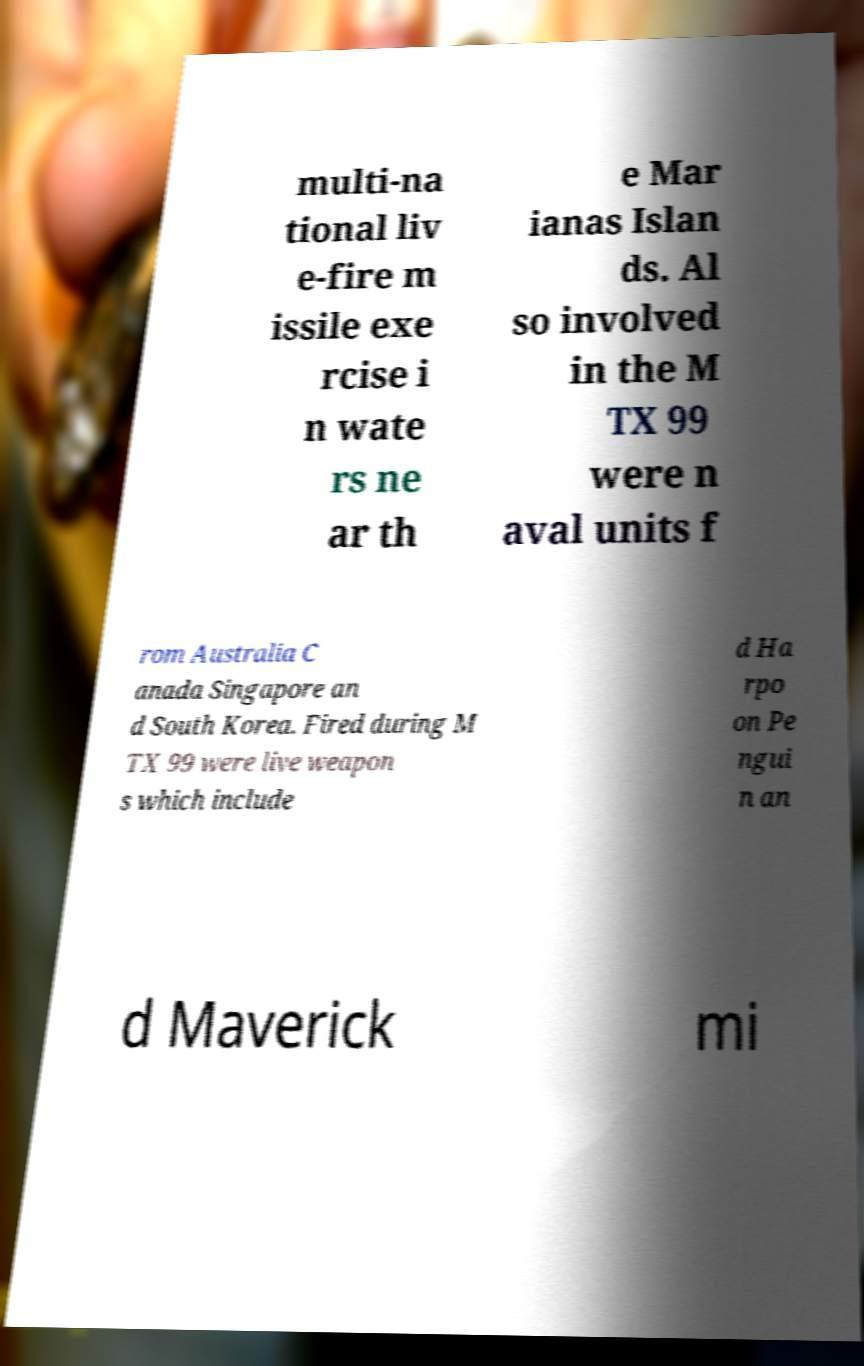Please identify and transcribe the text found in this image. multi-na tional liv e-fire m issile exe rcise i n wate rs ne ar th e Mar ianas Islan ds. Al so involved in the M TX 99 were n aval units f rom Australia C anada Singapore an d South Korea. Fired during M TX 99 were live weapon s which include d Ha rpo on Pe ngui n an d Maverick mi 